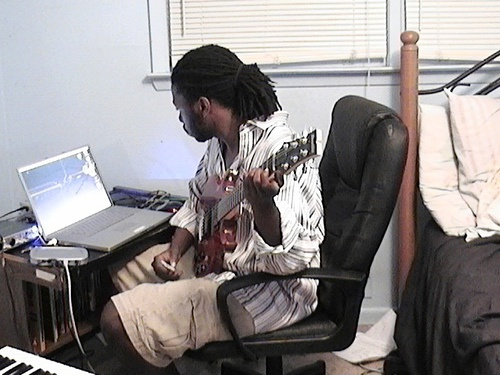Describe the objects in this image and their specific colors. I can see people in lightgray, black, gray, and darkgray tones, chair in lightgray, black, gray, and darkgray tones, bed in lightgray, white, black, and gray tones, laptop in lightgray, lavender, and darkgray tones, and book in lightgray, darkgray, and gray tones in this image. 